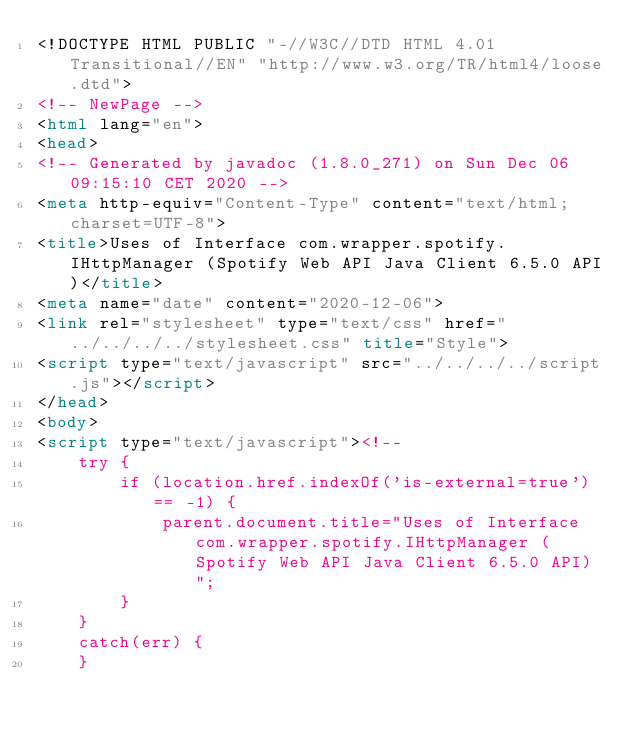<code> <loc_0><loc_0><loc_500><loc_500><_HTML_><!DOCTYPE HTML PUBLIC "-//W3C//DTD HTML 4.01 Transitional//EN" "http://www.w3.org/TR/html4/loose.dtd">
<!-- NewPage -->
<html lang="en">
<head>
<!-- Generated by javadoc (1.8.0_271) on Sun Dec 06 09:15:10 CET 2020 -->
<meta http-equiv="Content-Type" content="text/html; charset=UTF-8">
<title>Uses of Interface com.wrapper.spotify.IHttpManager (Spotify Web API Java Client 6.5.0 API)</title>
<meta name="date" content="2020-12-06">
<link rel="stylesheet" type="text/css" href="../../../../stylesheet.css" title="Style">
<script type="text/javascript" src="../../../../script.js"></script>
</head>
<body>
<script type="text/javascript"><!--
    try {
        if (location.href.indexOf('is-external=true') == -1) {
            parent.document.title="Uses of Interface com.wrapper.spotify.IHttpManager (Spotify Web API Java Client 6.5.0 API)";
        }
    }
    catch(err) {
    }</code> 